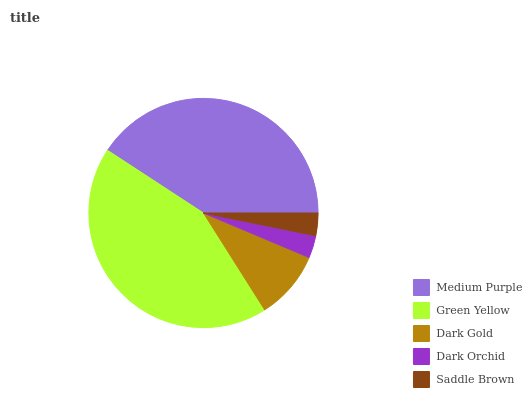Is Dark Orchid the minimum?
Answer yes or no. Yes. Is Green Yellow the maximum?
Answer yes or no. Yes. Is Dark Gold the minimum?
Answer yes or no. No. Is Dark Gold the maximum?
Answer yes or no. No. Is Green Yellow greater than Dark Gold?
Answer yes or no. Yes. Is Dark Gold less than Green Yellow?
Answer yes or no. Yes. Is Dark Gold greater than Green Yellow?
Answer yes or no. No. Is Green Yellow less than Dark Gold?
Answer yes or no. No. Is Dark Gold the high median?
Answer yes or no. Yes. Is Dark Gold the low median?
Answer yes or no. Yes. Is Green Yellow the high median?
Answer yes or no. No. Is Green Yellow the low median?
Answer yes or no. No. 